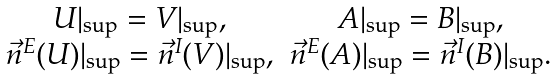Convert formula to latex. <formula><loc_0><loc_0><loc_500><loc_500>\begin{array} [ ] { c c } U | _ { \sup } = V | _ { \sup } , & A | _ { \sup } = B | _ { \sup } , \\ \vec { n } ^ { E } ( U ) | _ { \sup } = \vec { n } ^ { I } ( V ) | _ { \sup } , & \vec { n } ^ { E } ( A ) | _ { \sup } = \vec { n } ^ { I } ( B ) | _ { \sup } . \end{array}</formula> 